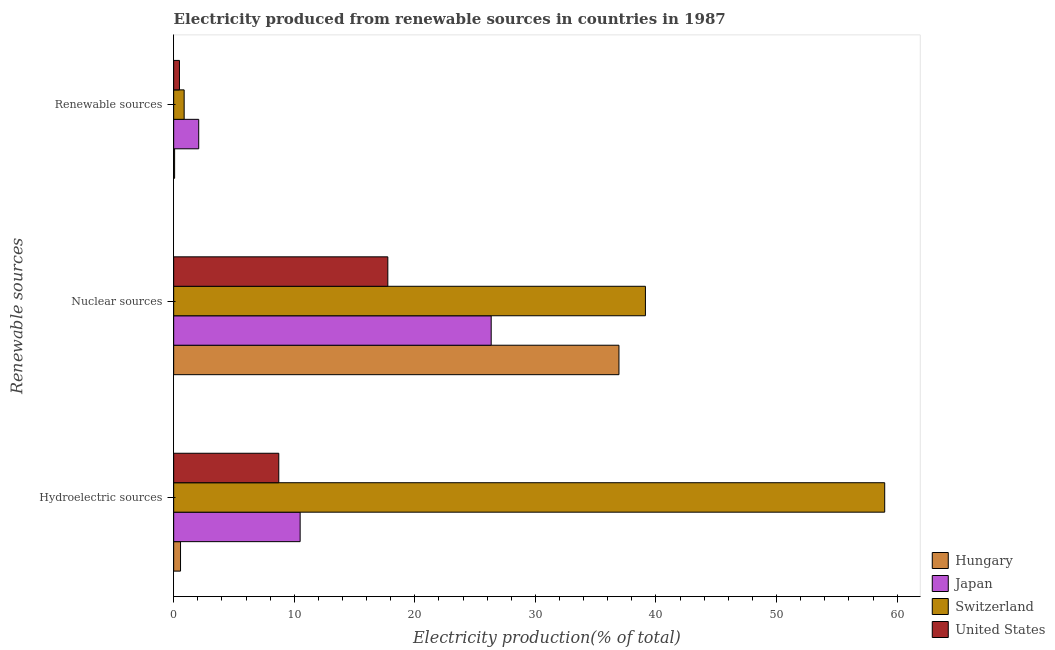Are the number of bars on each tick of the Y-axis equal?
Ensure brevity in your answer.  Yes. What is the label of the 2nd group of bars from the top?
Offer a very short reply. Nuclear sources. What is the percentage of electricity produced by nuclear sources in Hungary?
Provide a succinct answer. 36.93. Across all countries, what is the maximum percentage of electricity produced by nuclear sources?
Provide a succinct answer. 39.12. Across all countries, what is the minimum percentage of electricity produced by nuclear sources?
Give a very brief answer. 17.76. In which country was the percentage of electricity produced by nuclear sources maximum?
Provide a succinct answer. Switzerland. In which country was the percentage of electricity produced by renewable sources minimum?
Keep it short and to the point. Hungary. What is the total percentage of electricity produced by renewable sources in the graph?
Your answer should be very brief. 3.5. What is the difference between the percentage of electricity produced by nuclear sources in Switzerland and that in Hungary?
Make the answer very short. 2.2. What is the difference between the percentage of electricity produced by renewable sources in Japan and the percentage of electricity produced by hydroelectric sources in Switzerland?
Offer a terse response. -56.89. What is the average percentage of electricity produced by hydroelectric sources per country?
Provide a short and direct response. 19.69. What is the difference between the percentage of electricity produced by renewable sources and percentage of electricity produced by nuclear sources in United States?
Make the answer very short. -17.28. What is the ratio of the percentage of electricity produced by nuclear sources in Switzerland to that in Hungary?
Your answer should be compact. 1.06. Is the percentage of electricity produced by hydroelectric sources in Japan less than that in United States?
Provide a succinct answer. No. What is the difference between the highest and the second highest percentage of electricity produced by renewable sources?
Your response must be concise. 1.21. What is the difference between the highest and the lowest percentage of electricity produced by hydroelectric sources?
Ensure brevity in your answer.  58.4. In how many countries, is the percentage of electricity produced by nuclear sources greater than the average percentage of electricity produced by nuclear sources taken over all countries?
Your answer should be compact. 2. What does the 4th bar from the top in Hydroelectric sources represents?
Your response must be concise. Hungary. What does the 3rd bar from the bottom in Nuclear sources represents?
Offer a terse response. Switzerland. How many countries are there in the graph?
Your answer should be compact. 4. Does the graph contain any zero values?
Offer a terse response. No. Does the graph contain grids?
Your answer should be compact. No. How are the legend labels stacked?
Offer a very short reply. Vertical. What is the title of the graph?
Offer a terse response. Electricity produced from renewable sources in countries in 1987. Does "New Zealand" appear as one of the legend labels in the graph?
Your answer should be very brief. No. What is the label or title of the X-axis?
Your answer should be compact. Electricity production(% of total). What is the label or title of the Y-axis?
Your answer should be very brief. Renewable sources. What is the Electricity production(% of total) in Hungary in Hydroelectric sources?
Keep it short and to the point. 0.57. What is the Electricity production(% of total) in Japan in Hydroelectric sources?
Provide a succinct answer. 10.49. What is the Electricity production(% of total) in Switzerland in Hydroelectric sources?
Your answer should be very brief. 58.97. What is the Electricity production(% of total) in United States in Hydroelectric sources?
Offer a terse response. 8.72. What is the Electricity production(% of total) of Hungary in Nuclear sources?
Your response must be concise. 36.93. What is the Electricity production(% of total) in Japan in Nuclear sources?
Your answer should be very brief. 26.33. What is the Electricity production(% of total) of Switzerland in Nuclear sources?
Your answer should be compact. 39.12. What is the Electricity production(% of total) in United States in Nuclear sources?
Ensure brevity in your answer.  17.76. What is the Electricity production(% of total) of Hungary in Renewable sources?
Offer a very short reply. 0.08. What is the Electricity production(% of total) in Japan in Renewable sources?
Keep it short and to the point. 2.08. What is the Electricity production(% of total) in Switzerland in Renewable sources?
Your answer should be compact. 0.87. What is the Electricity production(% of total) in United States in Renewable sources?
Offer a very short reply. 0.48. Across all Renewable sources, what is the maximum Electricity production(% of total) of Hungary?
Your response must be concise. 36.93. Across all Renewable sources, what is the maximum Electricity production(% of total) of Japan?
Provide a succinct answer. 26.33. Across all Renewable sources, what is the maximum Electricity production(% of total) in Switzerland?
Offer a very short reply. 58.97. Across all Renewable sources, what is the maximum Electricity production(% of total) of United States?
Offer a terse response. 17.76. Across all Renewable sources, what is the minimum Electricity production(% of total) in Hungary?
Provide a succinct answer. 0.08. Across all Renewable sources, what is the minimum Electricity production(% of total) of Japan?
Offer a terse response. 2.08. Across all Renewable sources, what is the minimum Electricity production(% of total) of Switzerland?
Your answer should be compact. 0.87. Across all Renewable sources, what is the minimum Electricity production(% of total) in United States?
Your response must be concise. 0.48. What is the total Electricity production(% of total) of Hungary in the graph?
Give a very brief answer. 37.57. What is the total Electricity production(% of total) in Japan in the graph?
Your answer should be compact. 38.9. What is the total Electricity production(% of total) of Switzerland in the graph?
Your answer should be very brief. 98.96. What is the total Electricity production(% of total) in United States in the graph?
Keep it short and to the point. 26.96. What is the difference between the Electricity production(% of total) of Hungary in Hydroelectric sources and that in Nuclear sources?
Your answer should be very brief. -36.36. What is the difference between the Electricity production(% of total) in Japan in Hydroelectric sources and that in Nuclear sources?
Keep it short and to the point. -15.84. What is the difference between the Electricity production(% of total) of Switzerland in Hydroelectric sources and that in Nuclear sources?
Provide a succinct answer. 19.85. What is the difference between the Electricity production(% of total) of United States in Hydroelectric sources and that in Nuclear sources?
Keep it short and to the point. -9.04. What is the difference between the Electricity production(% of total) in Hungary in Hydroelectric sources and that in Renewable sources?
Your answer should be compact. 0.49. What is the difference between the Electricity production(% of total) of Japan in Hydroelectric sources and that in Renewable sources?
Give a very brief answer. 8.41. What is the difference between the Electricity production(% of total) of Switzerland in Hydroelectric sources and that in Renewable sources?
Make the answer very short. 58.1. What is the difference between the Electricity production(% of total) of United States in Hydroelectric sources and that in Renewable sources?
Keep it short and to the point. 8.24. What is the difference between the Electricity production(% of total) in Hungary in Nuclear sources and that in Renewable sources?
Your response must be concise. 36.85. What is the difference between the Electricity production(% of total) of Japan in Nuclear sources and that in Renewable sources?
Your answer should be very brief. 24.26. What is the difference between the Electricity production(% of total) of Switzerland in Nuclear sources and that in Renewable sources?
Your answer should be compact. 38.26. What is the difference between the Electricity production(% of total) in United States in Nuclear sources and that in Renewable sources?
Your response must be concise. 17.28. What is the difference between the Electricity production(% of total) of Hungary in Hydroelectric sources and the Electricity production(% of total) of Japan in Nuclear sources?
Provide a short and direct response. -25.77. What is the difference between the Electricity production(% of total) of Hungary in Hydroelectric sources and the Electricity production(% of total) of Switzerland in Nuclear sources?
Give a very brief answer. -38.56. What is the difference between the Electricity production(% of total) of Hungary in Hydroelectric sources and the Electricity production(% of total) of United States in Nuclear sources?
Offer a very short reply. -17.19. What is the difference between the Electricity production(% of total) in Japan in Hydroelectric sources and the Electricity production(% of total) in Switzerland in Nuclear sources?
Provide a succinct answer. -28.64. What is the difference between the Electricity production(% of total) of Japan in Hydroelectric sources and the Electricity production(% of total) of United States in Nuclear sources?
Your answer should be compact. -7.27. What is the difference between the Electricity production(% of total) in Switzerland in Hydroelectric sources and the Electricity production(% of total) in United States in Nuclear sources?
Your response must be concise. 41.21. What is the difference between the Electricity production(% of total) in Hungary in Hydroelectric sources and the Electricity production(% of total) in Japan in Renewable sources?
Give a very brief answer. -1.51. What is the difference between the Electricity production(% of total) in Hungary in Hydroelectric sources and the Electricity production(% of total) in Switzerland in Renewable sources?
Provide a succinct answer. -0.3. What is the difference between the Electricity production(% of total) of Hungary in Hydroelectric sources and the Electricity production(% of total) of United States in Renewable sources?
Ensure brevity in your answer.  0.09. What is the difference between the Electricity production(% of total) in Japan in Hydroelectric sources and the Electricity production(% of total) in Switzerland in Renewable sources?
Provide a short and direct response. 9.62. What is the difference between the Electricity production(% of total) of Japan in Hydroelectric sources and the Electricity production(% of total) of United States in Renewable sources?
Your answer should be very brief. 10.01. What is the difference between the Electricity production(% of total) in Switzerland in Hydroelectric sources and the Electricity production(% of total) in United States in Renewable sources?
Keep it short and to the point. 58.49. What is the difference between the Electricity production(% of total) of Hungary in Nuclear sources and the Electricity production(% of total) of Japan in Renewable sources?
Keep it short and to the point. 34.85. What is the difference between the Electricity production(% of total) of Hungary in Nuclear sources and the Electricity production(% of total) of Switzerland in Renewable sources?
Provide a short and direct response. 36.06. What is the difference between the Electricity production(% of total) in Hungary in Nuclear sources and the Electricity production(% of total) in United States in Renewable sources?
Ensure brevity in your answer.  36.45. What is the difference between the Electricity production(% of total) of Japan in Nuclear sources and the Electricity production(% of total) of Switzerland in Renewable sources?
Your answer should be compact. 25.46. What is the difference between the Electricity production(% of total) in Japan in Nuclear sources and the Electricity production(% of total) in United States in Renewable sources?
Provide a succinct answer. 25.85. What is the difference between the Electricity production(% of total) in Switzerland in Nuclear sources and the Electricity production(% of total) in United States in Renewable sources?
Keep it short and to the point. 38.65. What is the average Electricity production(% of total) in Hungary per Renewable sources?
Offer a terse response. 12.52. What is the average Electricity production(% of total) of Japan per Renewable sources?
Provide a succinct answer. 12.97. What is the average Electricity production(% of total) in Switzerland per Renewable sources?
Offer a terse response. 32.99. What is the average Electricity production(% of total) in United States per Renewable sources?
Provide a succinct answer. 8.99. What is the difference between the Electricity production(% of total) of Hungary and Electricity production(% of total) of Japan in Hydroelectric sources?
Make the answer very short. -9.92. What is the difference between the Electricity production(% of total) of Hungary and Electricity production(% of total) of Switzerland in Hydroelectric sources?
Your response must be concise. -58.4. What is the difference between the Electricity production(% of total) in Hungary and Electricity production(% of total) in United States in Hydroelectric sources?
Ensure brevity in your answer.  -8.15. What is the difference between the Electricity production(% of total) in Japan and Electricity production(% of total) in Switzerland in Hydroelectric sources?
Provide a succinct answer. -48.48. What is the difference between the Electricity production(% of total) in Japan and Electricity production(% of total) in United States in Hydroelectric sources?
Offer a very short reply. 1.77. What is the difference between the Electricity production(% of total) in Switzerland and Electricity production(% of total) in United States in Hydroelectric sources?
Keep it short and to the point. 50.25. What is the difference between the Electricity production(% of total) in Hungary and Electricity production(% of total) in Japan in Nuclear sources?
Give a very brief answer. 10.6. What is the difference between the Electricity production(% of total) in Hungary and Electricity production(% of total) in Switzerland in Nuclear sources?
Give a very brief answer. -2.2. What is the difference between the Electricity production(% of total) in Hungary and Electricity production(% of total) in United States in Nuclear sources?
Your response must be concise. 19.17. What is the difference between the Electricity production(% of total) of Japan and Electricity production(% of total) of Switzerland in Nuclear sources?
Provide a short and direct response. -12.79. What is the difference between the Electricity production(% of total) in Japan and Electricity production(% of total) in United States in Nuclear sources?
Your answer should be compact. 8.57. What is the difference between the Electricity production(% of total) in Switzerland and Electricity production(% of total) in United States in Nuclear sources?
Your answer should be very brief. 21.36. What is the difference between the Electricity production(% of total) of Hungary and Electricity production(% of total) of Japan in Renewable sources?
Ensure brevity in your answer.  -2. What is the difference between the Electricity production(% of total) of Hungary and Electricity production(% of total) of Switzerland in Renewable sources?
Keep it short and to the point. -0.79. What is the difference between the Electricity production(% of total) in Hungary and Electricity production(% of total) in United States in Renewable sources?
Give a very brief answer. -0.4. What is the difference between the Electricity production(% of total) in Japan and Electricity production(% of total) in Switzerland in Renewable sources?
Keep it short and to the point. 1.21. What is the difference between the Electricity production(% of total) in Japan and Electricity production(% of total) in United States in Renewable sources?
Keep it short and to the point. 1.6. What is the difference between the Electricity production(% of total) of Switzerland and Electricity production(% of total) of United States in Renewable sources?
Your answer should be very brief. 0.39. What is the ratio of the Electricity production(% of total) in Hungary in Hydroelectric sources to that in Nuclear sources?
Your response must be concise. 0.02. What is the ratio of the Electricity production(% of total) in Japan in Hydroelectric sources to that in Nuclear sources?
Provide a short and direct response. 0.4. What is the ratio of the Electricity production(% of total) of Switzerland in Hydroelectric sources to that in Nuclear sources?
Make the answer very short. 1.51. What is the ratio of the Electricity production(% of total) in United States in Hydroelectric sources to that in Nuclear sources?
Give a very brief answer. 0.49. What is the ratio of the Electricity production(% of total) of Hungary in Hydroelectric sources to that in Renewable sources?
Ensure brevity in your answer.  7.35. What is the ratio of the Electricity production(% of total) of Japan in Hydroelectric sources to that in Renewable sources?
Offer a terse response. 5.05. What is the ratio of the Electricity production(% of total) of Switzerland in Hydroelectric sources to that in Renewable sources?
Provide a succinct answer. 67.85. What is the ratio of the Electricity production(% of total) of United States in Hydroelectric sources to that in Renewable sources?
Ensure brevity in your answer.  18.2. What is the ratio of the Electricity production(% of total) in Hungary in Nuclear sources to that in Renewable sources?
Provide a succinct answer. 477.65. What is the ratio of the Electricity production(% of total) of Japan in Nuclear sources to that in Renewable sources?
Keep it short and to the point. 12.68. What is the ratio of the Electricity production(% of total) in Switzerland in Nuclear sources to that in Renewable sources?
Your answer should be very brief. 45.02. What is the ratio of the Electricity production(% of total) in United States in Nuclear sources to that in Renewable sources?
Your answer should be very brief. 37.08. What is the difference between the highest and the second highest Electricity production(% of total) in Hungary?
Your response must be concise. 36.36. What is the difference between the highest and the second highest Electricity production(% of total) in Japan?
Give a very brief answer. 15.84. What is the difference between the highest and the second highest Electricity production(% of total) in Switzerland?
Offer a very short reply. 19.85. What is the difference between the highest and the second highest Electricity production(% of total) in United States?
Give a very brief answer. 9.04. What is the difference between the highest and the lowest Electricity production(% of total) in Hungary?
Your answer should be very brief. 36.85. What is the difference between the highest and the lowest Electricity production(% of total) in Japan?
Offer a terse response. 24.26. What is the difference between the highest and the lowest Electricity production(% of total) of Switzerland?
Your response must be concise. 58.1. What is the difference between the highest and the lowest Electricity production(% of total) in United States?
Make the answer very short. 17.28. 